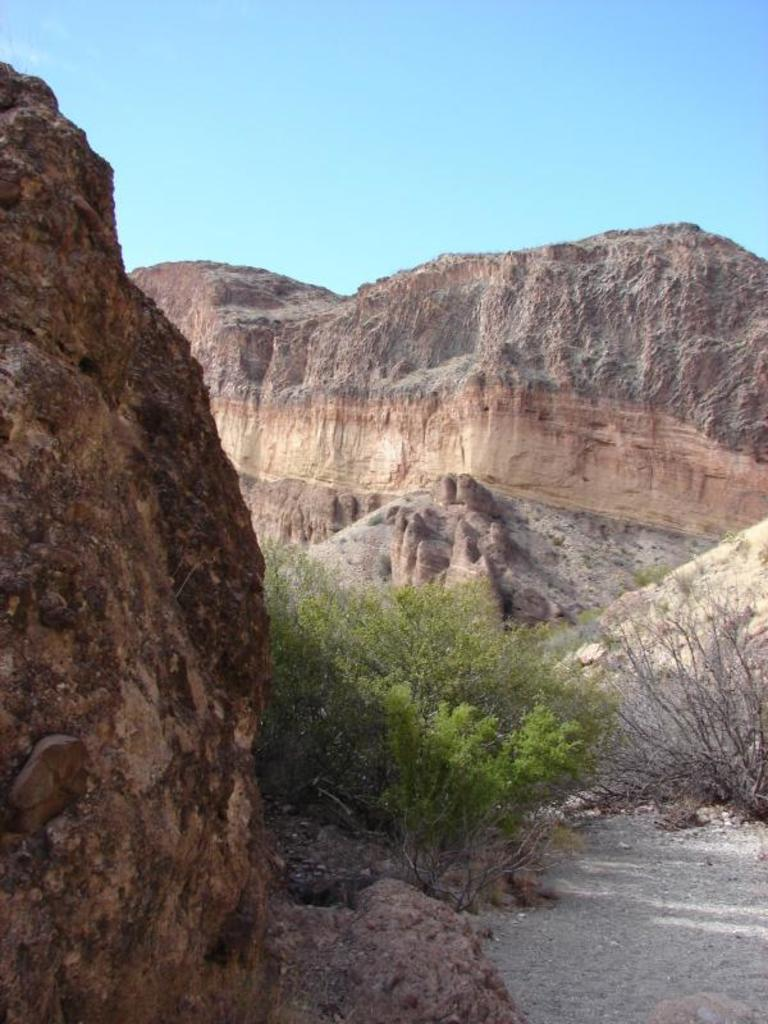What type of natural features can be seen in the image? There are trees and mountains in the image. What part of the natural environment is visible in the image? The sky is visible in the image. Based on the presence of the sky and the absence of stars or a moon, can we infer when the image was likely taken? Yes, the image was likely taken during the day. What type of juice is being served during the operation in the image? There is no juice or operation present in the image; it features trees, mountains, and the sky. 